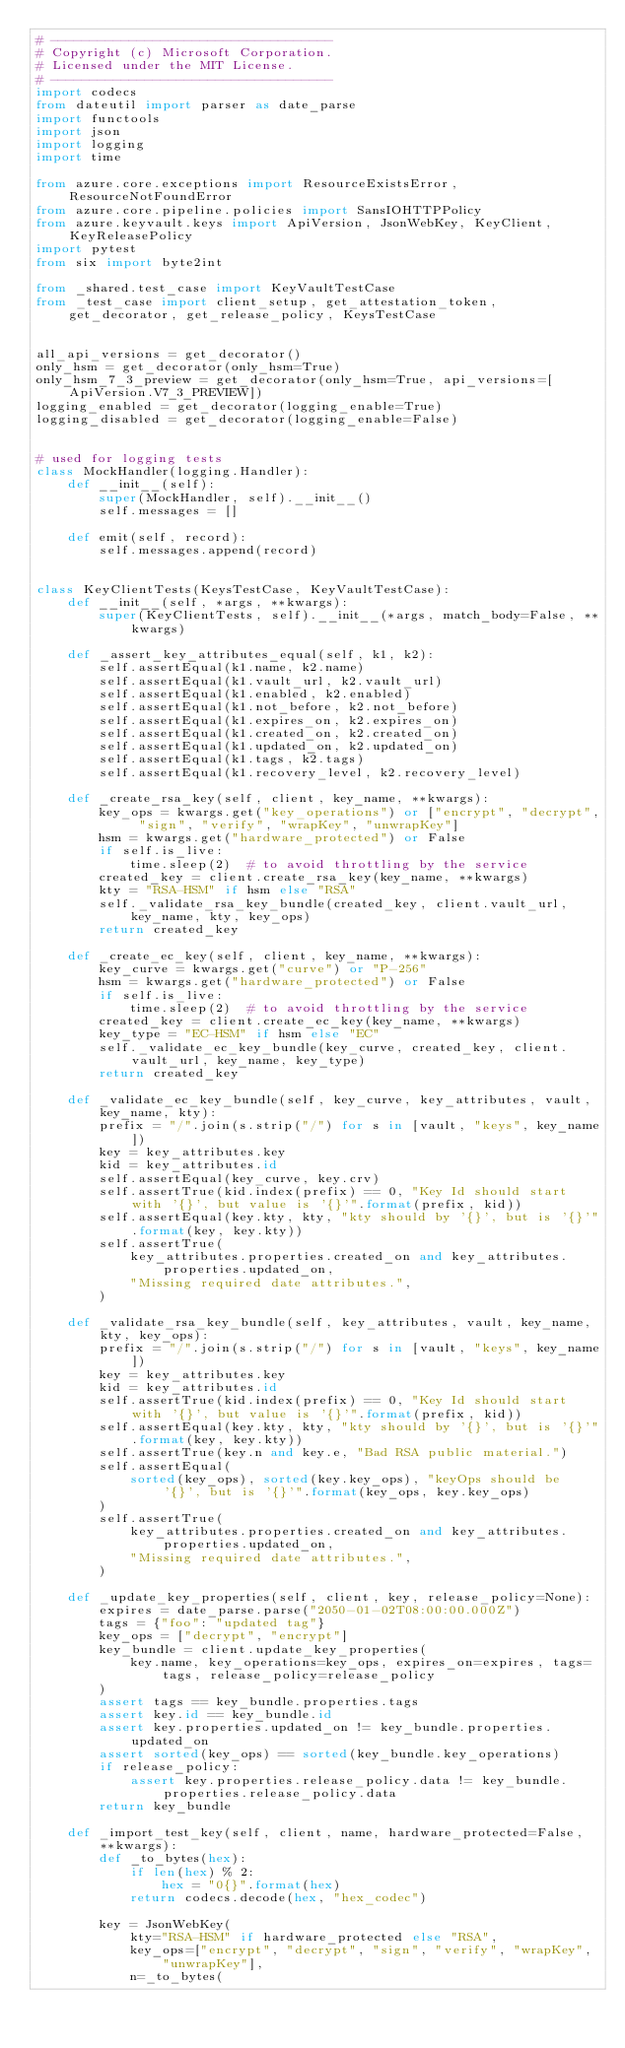Convert code to text. <code><loc_0><loc_0><loc_500><loc_500><_Python_># ------------------------------------
# Copyright (c) Microsoft Corporation.
# Licensed under the MIT License.
# ------------------------------------
import codecs
from dateutil import parser as date_parse
import functools
import json
import logging
import time

from azure.core.exceptions import ResourceExistsError, ResourceNotFoundError
from azure.core.pipeline.policies import SansIOHTTPPolicy
from azure.keyvault.keys import ApiVersion, JsonWebKey, KeyClient, KeyReleasePolicy
import pytest
from six import byte2int

from _shared.test_case import KeyVaultTestCase
from _test_case import client_setup, get_attestation_token, get_decorator, get_release_policy, KeysTestCase


all_api_versions = get_decorator()
only_hsm = get_decorator(only_hsm=True)
only_hsm_7_3_preview = get_decorator(only_hsm=True, api_versions=[ApiVersion.V7_3_PREVIEW])
logging_enabled = get_decorator(logging_enable=True)
logging_disabled = get_decorator(logging_enable=False)


# used for logging tests
class MockHandler(logging.Handler):
    def __init__(self):
        super(MockHandler, self).__init__()
        self.messages = []

    def emit(self, record):
        self.messages.append(record)


class KeyClientTests(KeysTestCase, KeyVaultTestCase):
    def __init__(self, *args, **kwargs):
        super(KeyClientTests, self).__init__(*args, match_body=False, **kwargs)

    def _assert_key_attributes_equal(self, k1, k2):
        self.assertEqual(k1.name, k2.name)
        self.assertEqual(k1.vault_url, k2.vault_url)
        self.assertEqual(k1.enabled, k2.enabled)
        self.assertEqual(k1.not_before, k2.not_before)
        self.assertEqual(k1.expires_on, k2.expires_on)
        self.assertEqual(k1.created_on, k2.created_on)
        self.assertEqual(k1.updated_on, k2.updated_on)
        self.assertEqual(k1.tags, k2.tags)
        self.assertEqual(k1.recovery_level, k2.recovery_level)

    def _create_rsa_key(self, client, key_name, **kwargs):
        key_ops = kwargs.get("key_operations") or ["encrypt", "decrypt", "sign", "verify", "wrapKey", "unwrapKey"]
        hsm = kwargs.get("hardware_protected") or False
        if self.is_live:
            time.sleep(2)  # to avoid throttling by the service
        created_key = client.create_rsa_key(key_name, **kwargs)
        kty = "RSA-HSM" if hsm else "RSA"
        self._validate_rsa_key_bundle(created_key, client.vault_url, key_name, kty, key_ops)
        return created_key

    def _create_ec_key(self, client, key_name, **kwargs):
        key_curve = kwargs.get("curve") or "P-256"
        hsm = kwargs.get("hardware_protected") or False
        if self.is_live:
            time.sleep(2)  # to avoid throttling by the service
        created_key = client.create_ec_key(key_name, **kwargs)
        key_type = "EC-HSM" if hsm else "EC"
        self._validate_ec_key_bundle(key_curve, created_key, client.vault_url, key_name, key_type)
        return created_key

    def _validate_ec_key_bundle(self, key_curve, key_attributes, vault, key_name, kty):
        prefix = "/".join(s.strip("/") for s in [vault, "keys", key_name])
        key = key_attributes.key
        kid = key_attributes.id
        self.assertEqual(key_curve, key.crv)
        self.assertTrue(kid.index(prefix) == 0, "Key Id should start with '{}', but value is '{}'".format(prefix, kid))
        self.assertEqual(key.kty, kty, "kty should by '{}', but is '{}'".format(key, key.kty))
        self.assertTrue(
            key_attributes.properties.created_on and key_attributes.properties.updated_on,
            "Missing required date attributes.",
        )

    def _validate_rsa_key_bundle(self, key_attributes, vault, key_name, kty, key_ops):
        prefix = "/".join(s.strip("/") for s in [vault, "keys", key_name])
        key = key_attributes.key
        kid = key_attributes.id
        self.assertTrue(kid.index(prefix) == 0, "Key Id should start with '{}', but value is '{}'".format(prefix, kid))
        self.assertEqual(key.kty, kty, "kty should by '{}', but is '{}'".format(key, key.kty))
        self.assertTrue(key.n and key.e, "Bad RSA public material.")
        self.assertEqual(
            sorted(key_ops), sorted(key.key_ops), "keyOps should be '{}', but is '{}'".format(key_ops, key.key_ops)
        )
        self.assertTrue(
            key_attributes.properties.created_on and key_attributes.properties.updated_on,
            "Missing required date attributes.",
        )

    def _update_key_properties(self, client, key, release_policy=None):
        expires = date_parse.parse("2050-01-02T08:00:00.000Z")
        tags = {"foo": "updated tag"}
        key_ops = ["decrypt", "encrypt"]
        key_bundle = client.update_key_properties(
            key.name, key_operations=key_ops, expires_on=expires, tags=tags, release_policy=release_policy
        )
        assert tags == key_bundle.properties.tags
        assert key.id == key_bundle.id
        assert key.properties.updated_on != key_bundle.properties.updated_on
        assert sorted(key_ops) == sorted(key_bundle.key_operations)
        if release_policy:
            assert key.properties.release_policy.data != key_bundle.properties.release_policy.data
        return key_bundle

    def _import_test_key(self, client, name, hardware_protected=False, **kwargs):
        def _to_bytes(hex):
            if len(hex) % 2:
                hex = "0{}".format(hex)
            return codecs.decode(hex, "hex_codec")

        key = JsonWebKey(
            kty="RSA-HSM" if hardware_protected else "RSA",
            key_ops=["encrypt", "decrypt", "sign", "verify", "wrapKey", "unwrapKey"],
            n=_to_bytes(</code> 